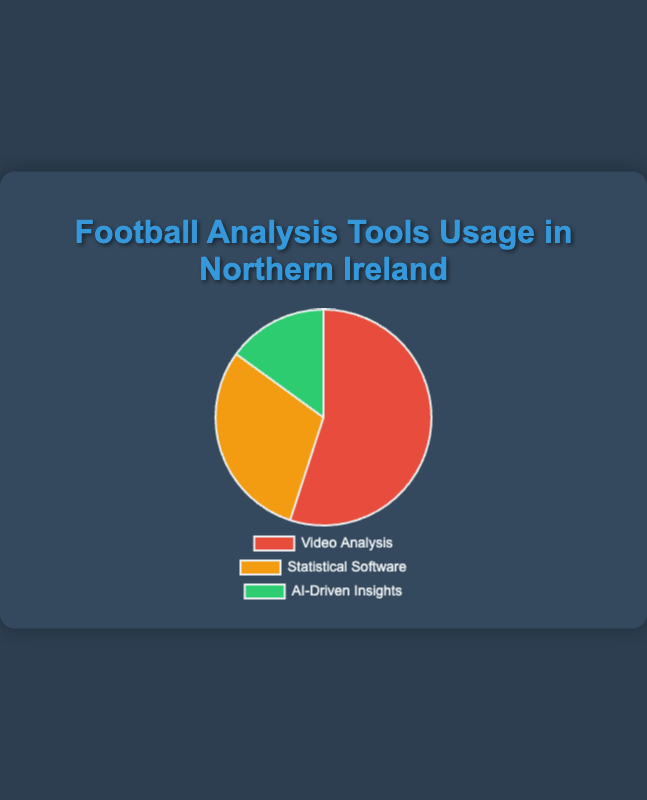What percentage of Northern Ireland football commentators use statistical software? Look at the section labeled "Statistical Software" in the pie chart, which indicates the percentage usage by that tool.
Answer: 30% What type of football analysis tool is most used by Northern Ireland commentators? Compare the sizes of all sections in the pie chart; the largest section represents the most-used tool. "Video Analysis" is the largest.
Answer: Video Analysis What is the combined percentage of commentators using Video Analysis and AI-Driven Insights tools? Sum the percentages of Video Analysis (55%) and AI-Driven Insights (15%). 55 + 15 = 70.
Answer: 70% Which analysis tool is used the least by Northern Ireland football commentators? Identify the smallest section in the pie chart; the smallest section corresponds to AI-Driven Insights.
Answer: AI-Driven Insights How does the usage of statistical software compare to AI-driven insights? Compare the two percentages: Statistical Software is 30%, while AI-Driven Insights is 15%. Statistical Software has twice the usage of AI-Driven Insights.
Answer: Statistical Software is used more Which two types of tools together account for 85% of the usage among Northern Ireland commentators? Identify two segments whose percentages sum up to 85%. Video Analysis (55%) + Statistical Software (30%) = 85%.
Answer: Video Analysis and Statistical Software What color represents the least used tool in the pie chart? The section representing "AI-Driven Insights" is the smallest, and this section is colored green.
Answer: Green What is the difference in percentage usage between Video Analysis and Statistical Software? Subtract the percentage of Statistical Software (30%) from that of Video Analysis (55%). 55 - 30 = 25.
Answer: 25% Which two tools have a total usage percentage greater than 60%? Identify pairs of tools and sum their percentages. Video Analysis (55%) + Statistical Software (30%) = 85%, which is greater than 60%.
Answer: Video Analysis and Statistical Software If you were to remove the AI-Driven Insights section, what percentage would the remaining sections sum to? Sum the percentages of Video Analysis (55%) and Statistical Software (30%). 55 + 30 = 85.
Answer: 85% 